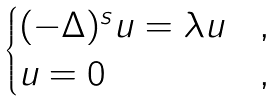Convert formula to latex. <formula><loc_0><loc_0><loc_500><loc_500>\begin{cases} ( - \Delta ) ^ { s } u = \lambda u & , \\ u = 0 & , \end{cases}</formula> 